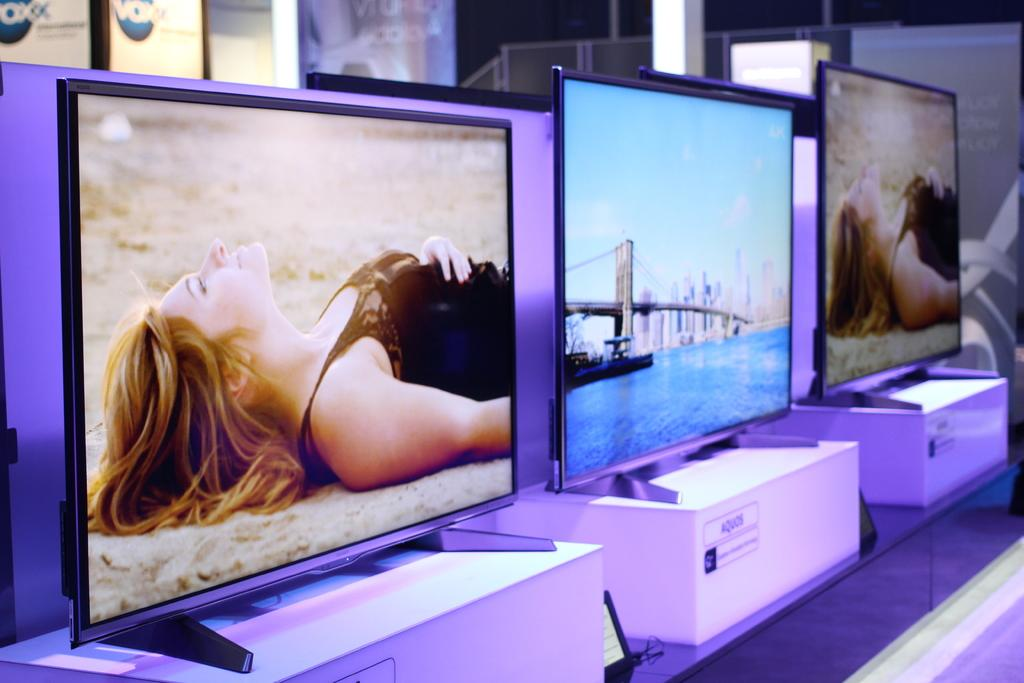<image>
Provide a brief description of the given image. An assortment of televisions are displayed in a VOXX show room. 